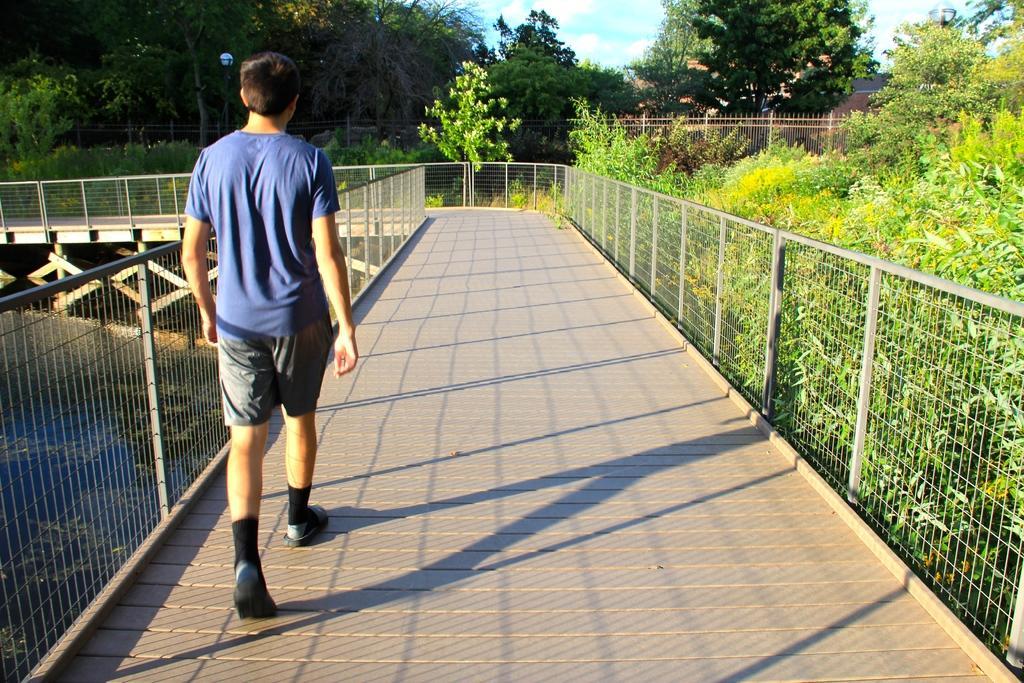Describe this image in one or two sentences. In this image I can see the person walking on the bridge. The person is wearing the blue and grey color dress. To the side of the person I can see the railing. To the left I can see the water and to the right there are plants. In the background I can see many trees and the sky. 